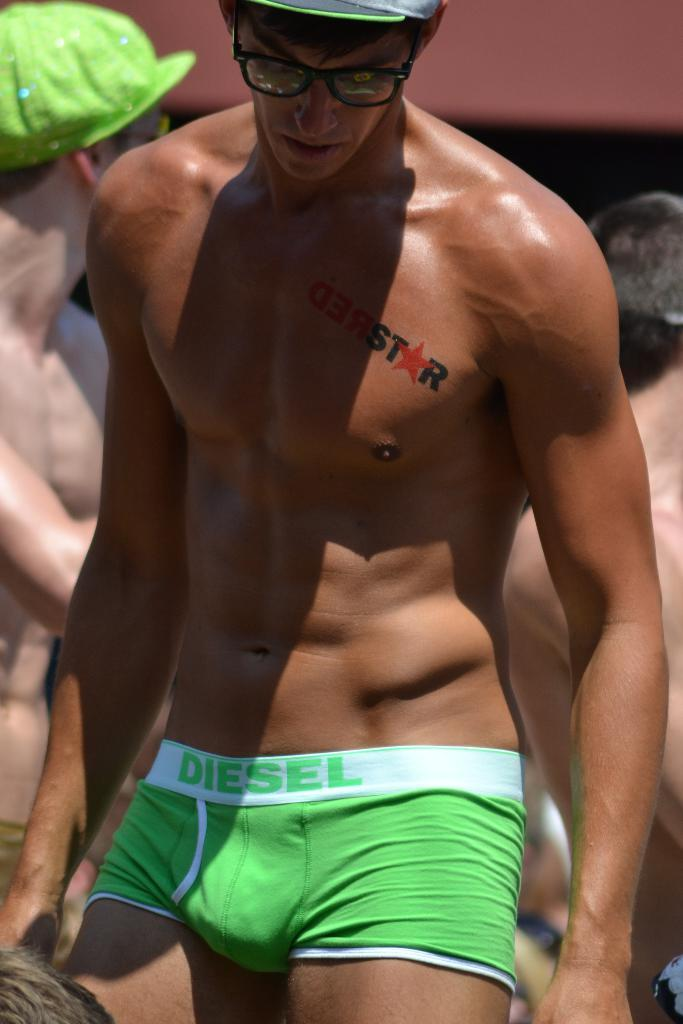Provide a one-sentence caption for the provided image. Man that is shirtless with a "RedStar" tattoo. 